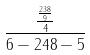<formula> <loc_0><loc_0><loc_500><loc_500>\frac { \frac { \frac { 2 3 8 } { 9 } } { 4 } } { 6 - 2 4 8 - 5 }</formula> 